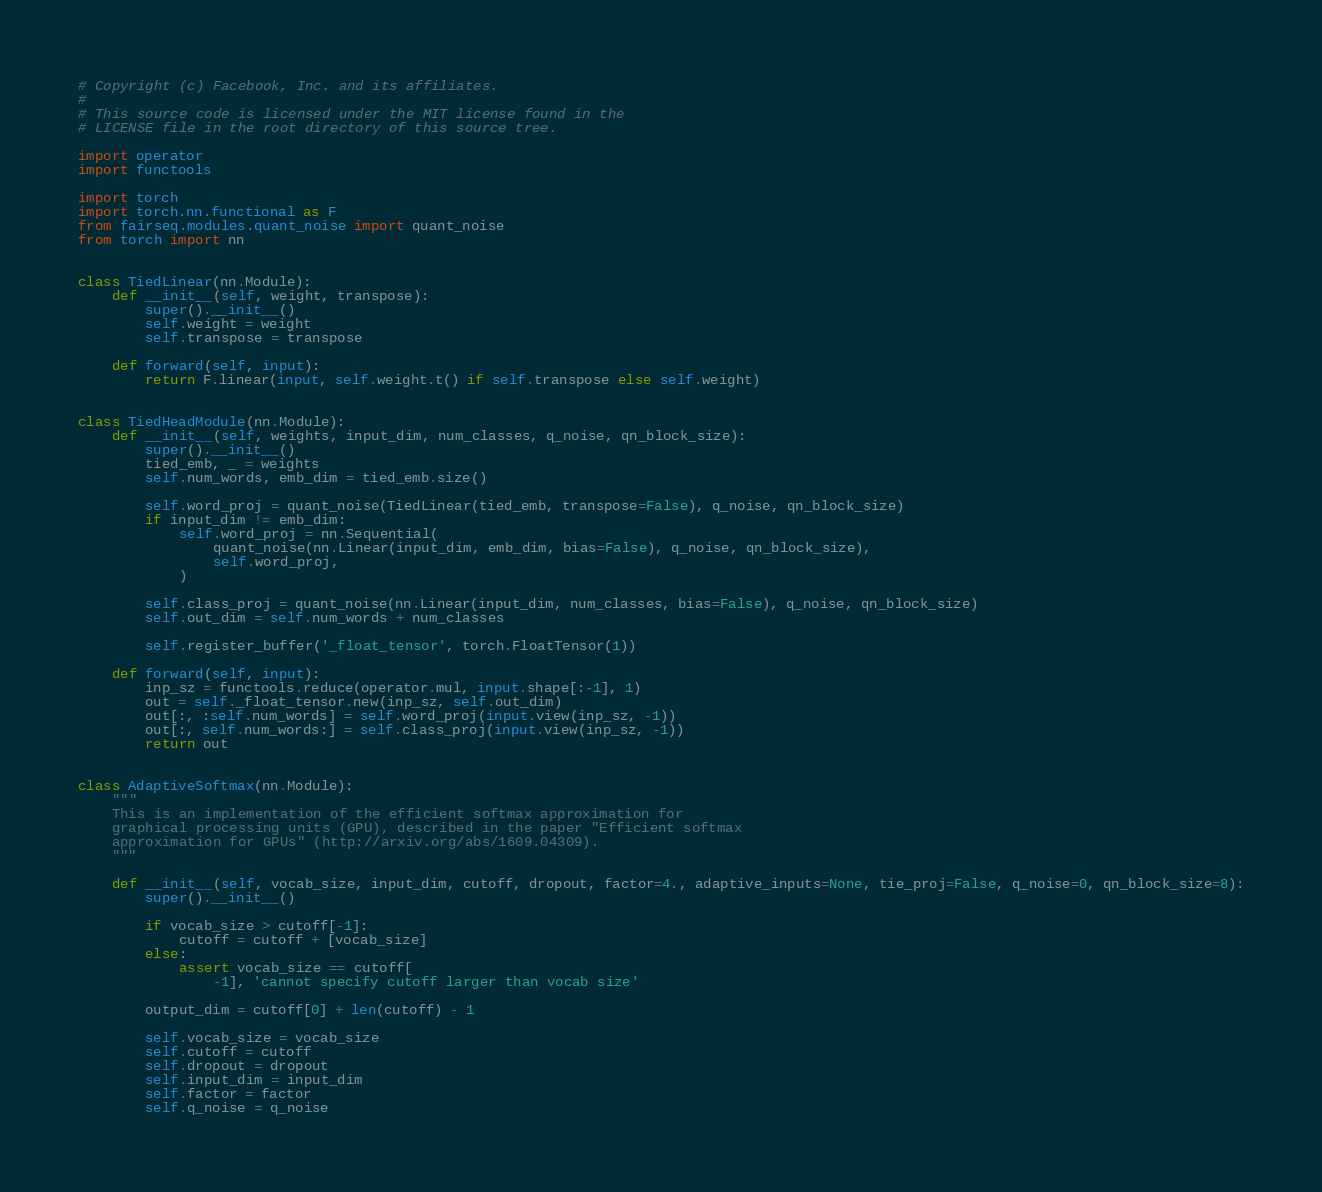<code> <loc_0><loc_0><loc_500><loc_500><_Python_># Copyright (c) Facebook, Inc. and its affiliates.
#
# This source code is licensed under the MIT license found in the
# LICENSE file in the root directory of this source tree.

import operator
import functools

import torch
import torch.nn.functional as F
from fairseq.modules.quant_noise import quant_noise
from torch import nn


class TiedLinear(nn.Module):
    def __init__(self, weight, transpose):
        super().__init__()
        self.weight = weight
        self.transpose = transpose

    def forward(self, input):
        return F.linear(input, self.weight.t() if self.transpose else self.weight)


class TiedHeadModule(nn.Module):
    def __init__(self, weights, input_dim, num_classes, q_noise, qn_block_size):
        super().__init__()
        tied_emb, _ = weights
        self.num_words, emb_dim = tied_emb.size()

        self.word_proj = quant_noise(TiedLinear(tied_emb, transpose=False), q_noise, qn_block_size)
        if input_dim != emb_dim:
            self.word_proj = nn.Sequential(
                quant_noise(nn.Linear(input_dim, emb_dim, bias=False), q_noise, qn_block_size),
                self.word_proj,
            )

        self.class_proj = quant_noise(nn.Linear(input_dim, num_classes, bias=False), q_noise, qn_block_size)
        self.out_dim = self.num_words + num_classes

        self.register_buffer('_float_tensor', torch.FloatTensor(1))

    def forward(self, input):
        inp_sz = functools.reduce(operator.mul, input.shape[:-1], 1)
        out = self._float_tensor.new(inp_sz, self.out_dim)
        out[:, :self.num_words] = self.word_proj(input.view(inp_sz, -1))
        out[:, self.num_words:] = self.class_proj(input.view(inp_sz, -1))
        return out


class AdaptiveSoftmax(nn.Module):
    """
    This is an implementation of the efficient softmax approximation for
    graphical processing units (GPU), described in the paper "Efficient softmax
    approximation for GPUs" (http://arxiv.org/abs/1609.04309).
    """

    def __init__(self, vocab_size, input_dim, cutoff, dropout, factor=4., adaptive_inputs=None, tie_proj=False, q_noise=0, qn_block_size=8):
        super().__init__()

        if vocab_size > cutoff[-1]:
            cutoff = cutoff + [vocab_size]
        else:
            assert vocab_size == cutoff[
                -1], 'cannot specify cutoff larger than vocab size'

        output_dim = cutoff[0] + len(cutoff) - 1

        self.vocab_size = vocab_size
        self.cutoff = cutoff
        self.dropout = dropout
        self.input_dim = input_dim
        self.factor = factor
        self.q_noise = q_noise</code> 